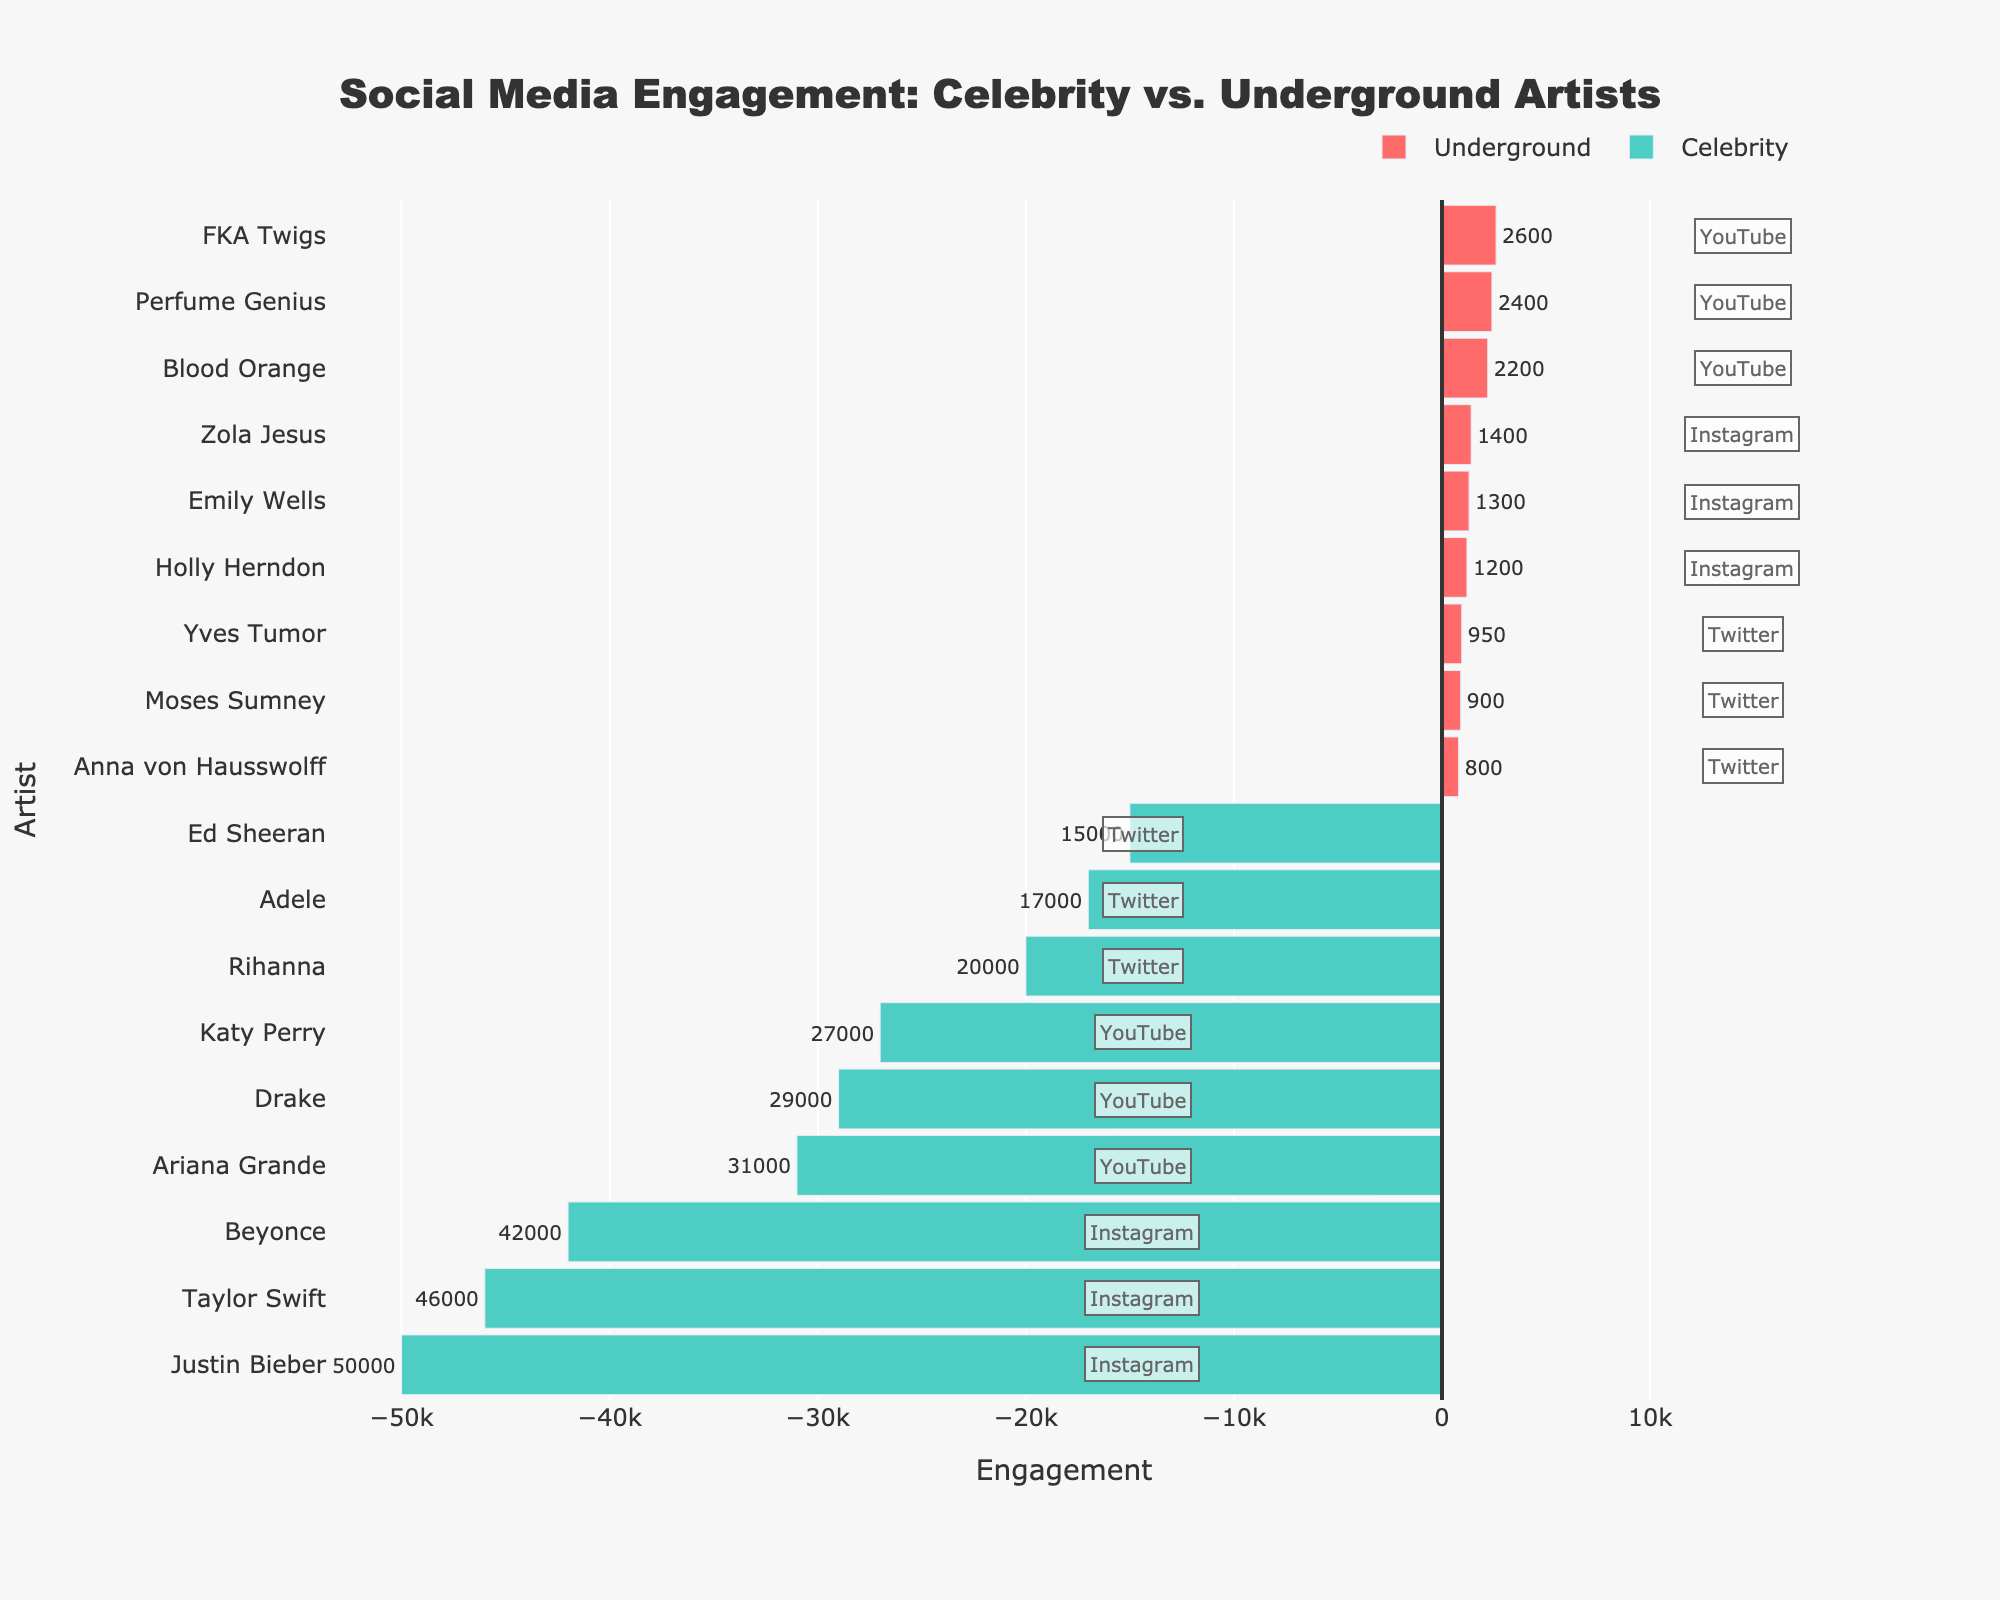What's the engagement difference between the most engaged celebrity on Instagram and the most engaged underground artist on Instagram? The most engaged celebrity on Instagram is Justin Bieber with 50,000, and the most engaged underground artist on Instagram is Zola Jesus with 1,400. The difference in engagement is 50,000 - 1,400
Answer: 48,600 Which platform sees the highest engagement for celebrities? Taylor Swift on Instagram has the highest engagement with 46,000, comparing Instagram, YouTube, and Twitter for all celebrity artists; Instagram generally shows higher engagement
Answer: Instagram What's the combined engagement for underground artists on Twitter? Anna von Hausswolff has 800, Moses Sumney has 900, and Yves Tumor has 950. Their combined engagement is 800 + 900 + 950
Answer: 2,650 Are there any platforms where an underground artist's engagement is higher than the lowest engaged celebrity artist on the same platform? The lowest engaged celebrity on Twitter is Ed Sheeran with 15,000. No underground artist outperforms him on any platform; their engagements are between 800 and 2,600
Answer: No Who is the least engaged artist among both groups on Instagram, and what is their engagement? Holly Herndon is the least engaged artist on Instagram with an engagement of 1,200; looking at all artists on Instagram, Holly Herndon has the lowest engagement
Answer: Holly Herndon, 1,200 What's the total engagement for all celebrity artists on YouTube? Adding Ariana Grande (31,000), Drake (29,000), and Katy Perry (27,000) results in 31,000 + 29,000 + 27,000
Answer: 87,000 Which underground artist has the lowest engagement and on which platform? Anna von Hausswolff on Twitter has the lowest engagement of 800, reviewing all underground artists' engagement across platforms
Answer: Anna von Hausswolff, Twitter Visually, which category has bars extending to the left side of the vertical line, and how does this help identify those artists? The 'Celebrity' category has bars extending to the left, colored in green, making it easy to identify celebrity artists visually
Answer: Celebrity, green What's the engagement range of underground artists on YouTube? Perfume Genius has 2,400, Blood Orange has 2,200, FKA Twigs has 2,600; the range is from the minimum 2,200 to maximum 2,600
Answer: 2,200 to 2,600 Which platform has the most balanced engagement between celebrity and underground artists? YouTube shows more balanced engagement, with celebrity artists ranging from 27,000 to 31,000 and underground from 2,200 to 2,600, compared to other platforms where engagement differences are larger
Answer: YouTube 